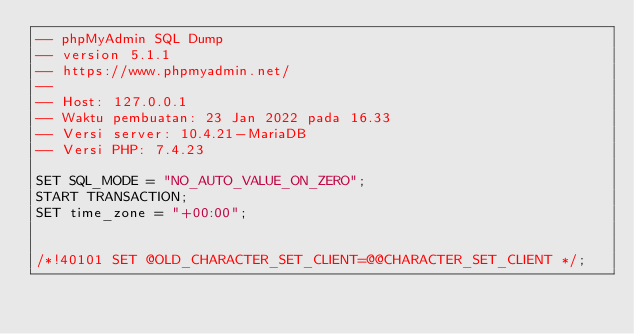Convert code to text. <code><loc_0><loc_0><loc_500><loc_500><_SQL_>-- phpMyAdmin SQL Dump
-- version 5.1.1
-- https://www.phpmyadmin.net/
--
-- Host: 127.0.0.1
-- Waktu pembuatan: 23 Jan 2022 pada 16.33
-- Versi server: 10.4.21-MariaDB
-- Versi PHP: 7.4.23

SET SQL_MODE = "NO_AUTO_VALUE_ON_ZERO";
START TRANSACTION;
SET time_zone = "+00:00";


/*!40101 SET @OLD_CHARACTER_SET_CLIENT=@@CHARACTER_SET_CLIENT */;</code> 